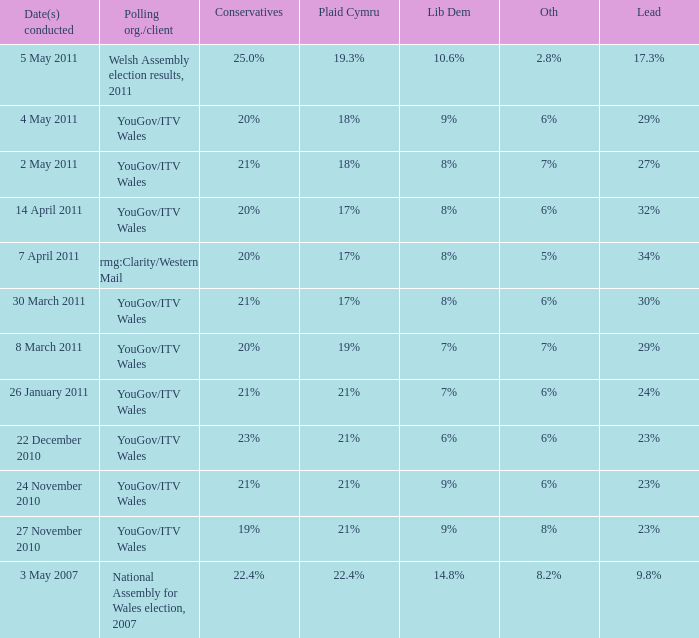I want the plaid cymru for Polling organisation/client of yougov/itv wales for 4 may 2011 18%. 